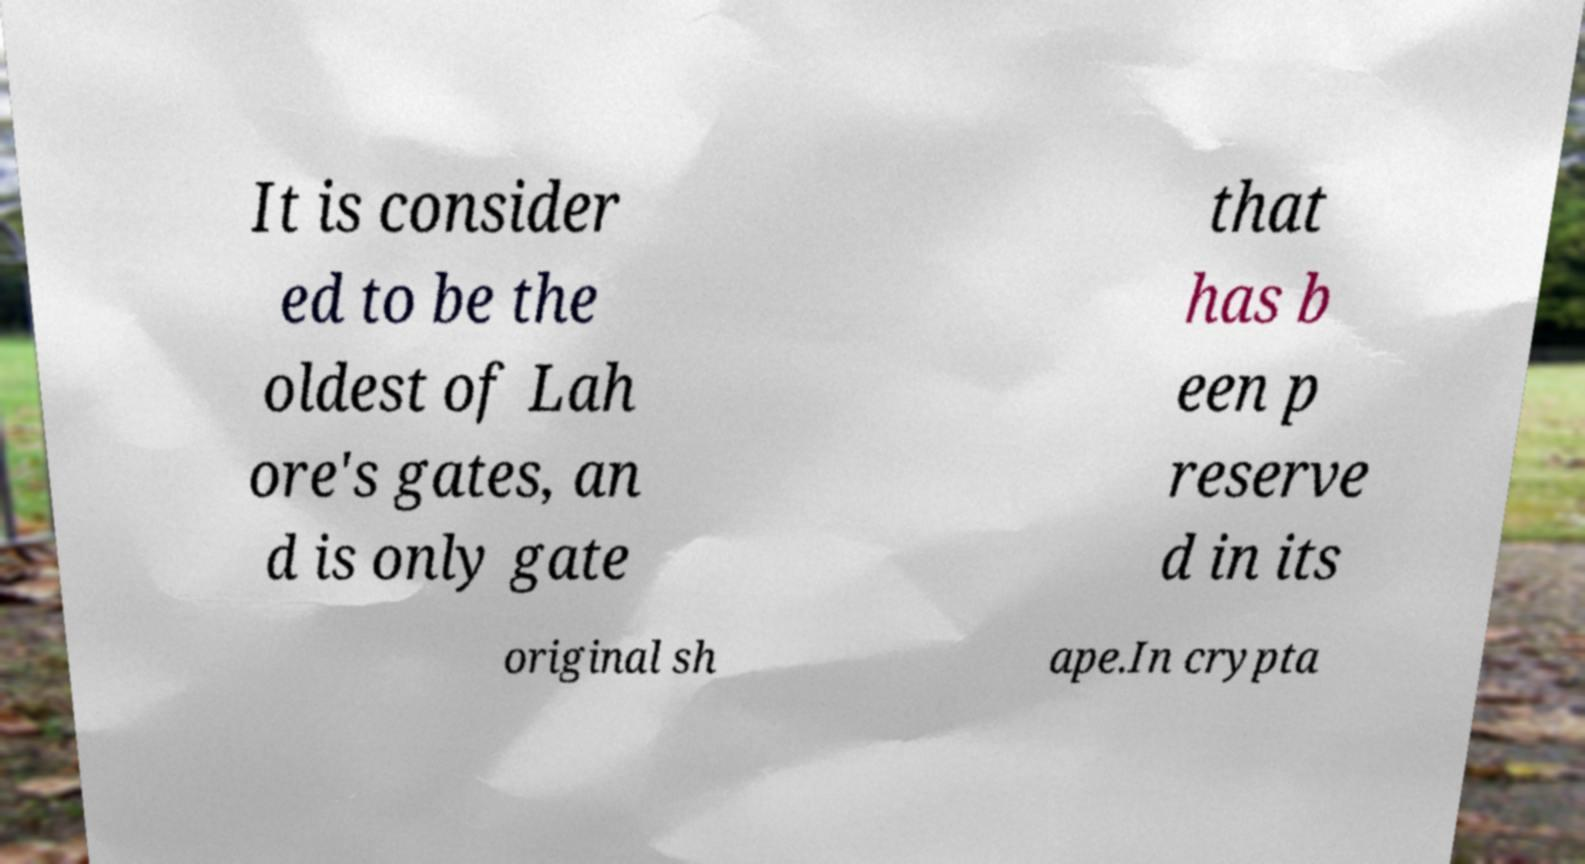For documentation purposes, I need the text within this image transcribed. Could you provide that? It is consider ed to be the oldest of Lah ore's gates, an d is only gate that has b een p reserve d in its original sh ape.In crypta 